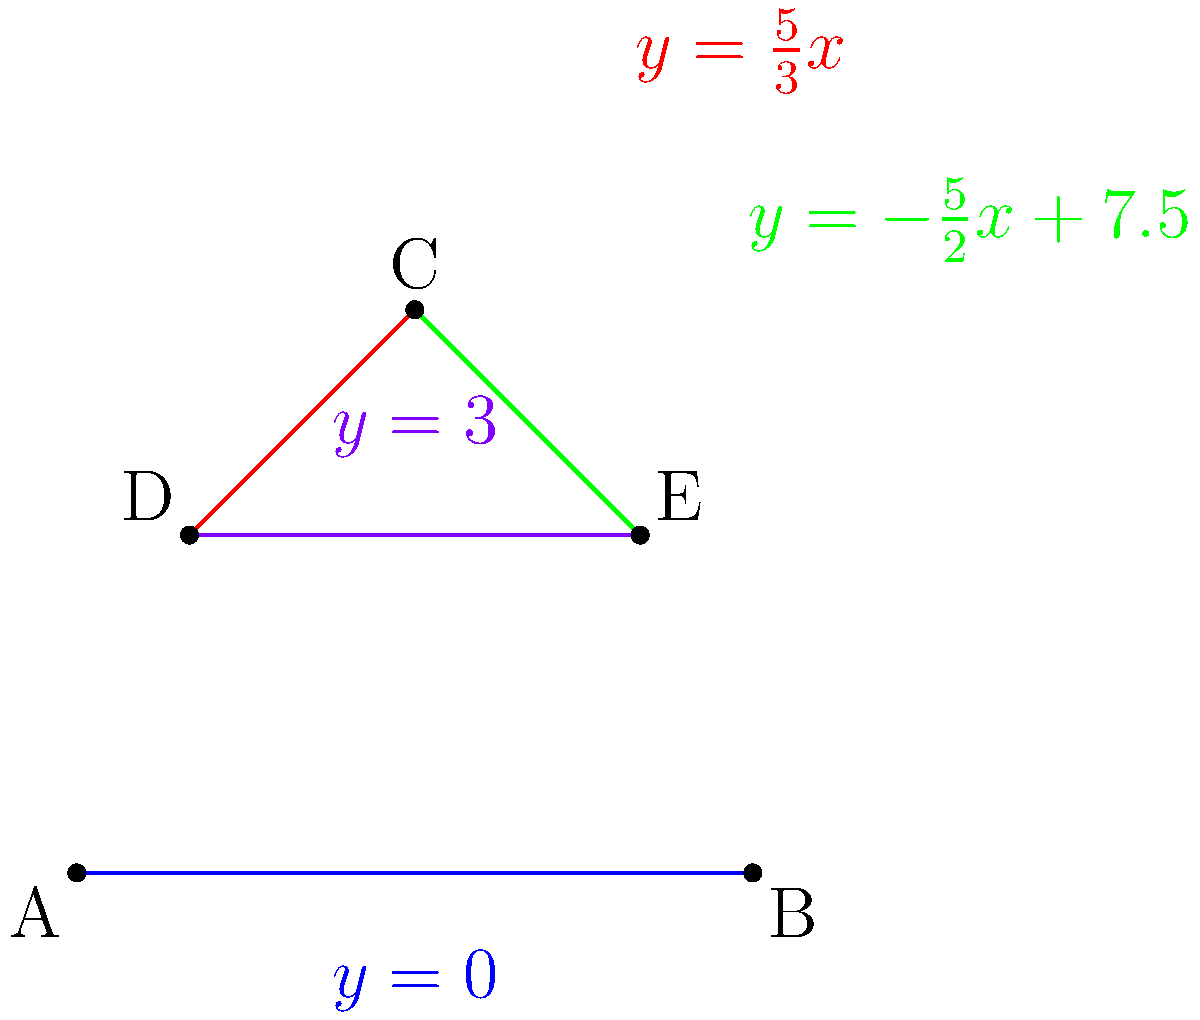In this artistic composition, four lines intersect to create a unique, non-traditional pattern. The lines are represented by the following equations:

1. $y = \frac{5}{3}x$
2. $y = -\frac{5}{2}x + 7.5$
3. $y = 3$
4. $y = 0$

Find the coordinates of all intersection points between these lines, excluding any points that lie outside the region bounded by $x = 0$ and $x = 6$. Let's find the intersection points step by step:

1. Line 1 and Line 2:
   $\frac{5}{3}x = -\frac{5}{2}x + 7.5$
   $\frac{25}{6}x = 7.5$
   $x = \frac{18}{5} = 3.6$
   $y = \frac{5}{3}(3.6) = 6$
   Point: $(3.6, 6)$

2. Line 1 and Line 3:
   $\frac{5}{3}x = 3$
   $x = 1.8$
   Point: $(1.8, 3)$

3. Line 1 and Line 4:
   $\frac{5}{3}x = 0$
   $x = 0$
   Point: $(0, 0)$

4. Line 2 and Line 3:
   $-\frac{5}{2}x + 7.5 = 3$
   $-\frac{5}{2}x = -4.5$
   $x = 1.8$
   Point: $(1.8, 3)$

5. Line 2 and Line 4:
   $-\frac{5}{2}x + 7.5 = 0$
   $x = 3$
   Point: $(3, 0)$

6. Line 3 and Line 4:
   These lines are parallel and do not intersect.

Filtering out points outside the region $0 \leq x \leq 6$, we're left with:
$(0, 0)$, $(1.8, 3)$, $(3, 0)$, and $(3.6, 6)$
Answer: $(0, 0)$, $(1.8, 3)$, $(3, 0)$, $(3.6, 6)$ 